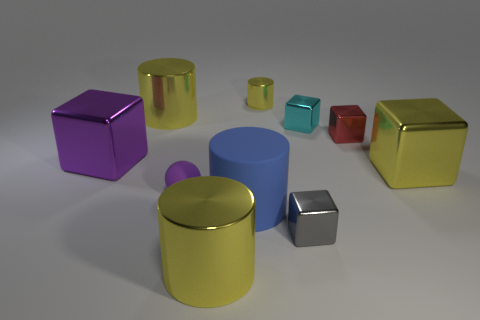Subtract all green cubes. How many yellow cylinders are left? 3 Subtract all yellow blocks. How many blocks are left? 4 Subtract all cyan cubes. How many cubes are left? 4 Subtract all red cubes. Subtract all yellow balls. How many cubes are left? 4 Subtract all spheres. How many objects are left? 9 Subtract 1 red cubes. How many objects are left? 9 Subtract all small cylinders. Subtract all matte spheres. How many objects are left? 8 Add 2 cyan cubes. How many cyan cubes are left? 3 Add 9 green rubber cylinders. How many green rubber cylinders exist? 9 